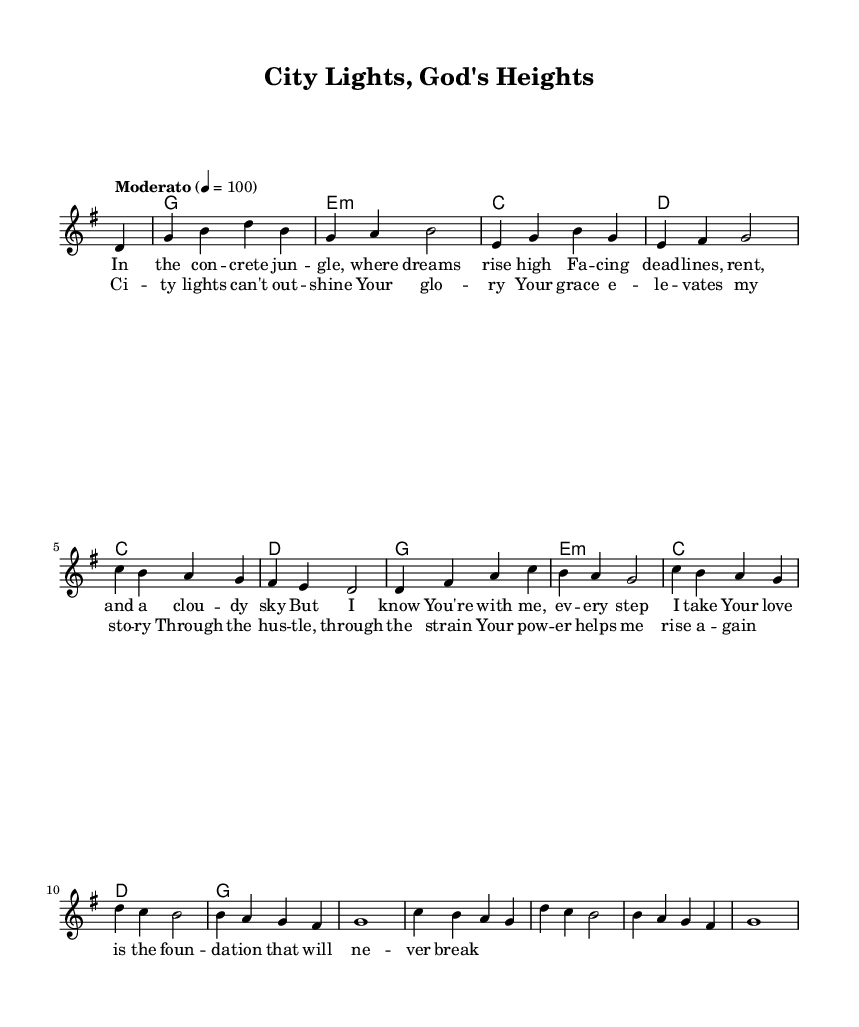what is the key signature of this music? The key signature is indicated at the beginning of the score, and it shows one sharp (F#), which confirms it is in G major.
Answer: G major what is the time signature of this music? The time signature is found at the beginning of the score, represented as a fraction. In this sheet music, it is shown as 4/4, which signifies four beats per measure.
Answer: 4/4 what is the tempo marking of this music? The tempo marking appears at the beginning of the piece, indicating how fast the music should be played. Here, it is marked as "Moderato," which suggests a moderate speed.
Answer: Moderato how many measures are in the melody? To find the number of measures, count the vertical lines called barlines in the melody section. There are 12 measures in total in the provided melody.
Answer: 12 what is the main theme of the lyrics? The lyrics focus on themes of overcoming challenges and finding support in faith amidst life's difficulties. This is inferred from the phrases used in the first verse and chorus.
Answer: Overcoming challenges what is the first note of the melody? The melody begins with a partial measure, indicated by the "partial 4" notation. The first full note that follows is D, which is the first actual note played in the melody.
Answer: D which chord follows after the first measure? The chord progression shows a chord symbol right after the first measure. Here, it is a G major chord, as indicated at the start of the harmony section.
Answer: G 